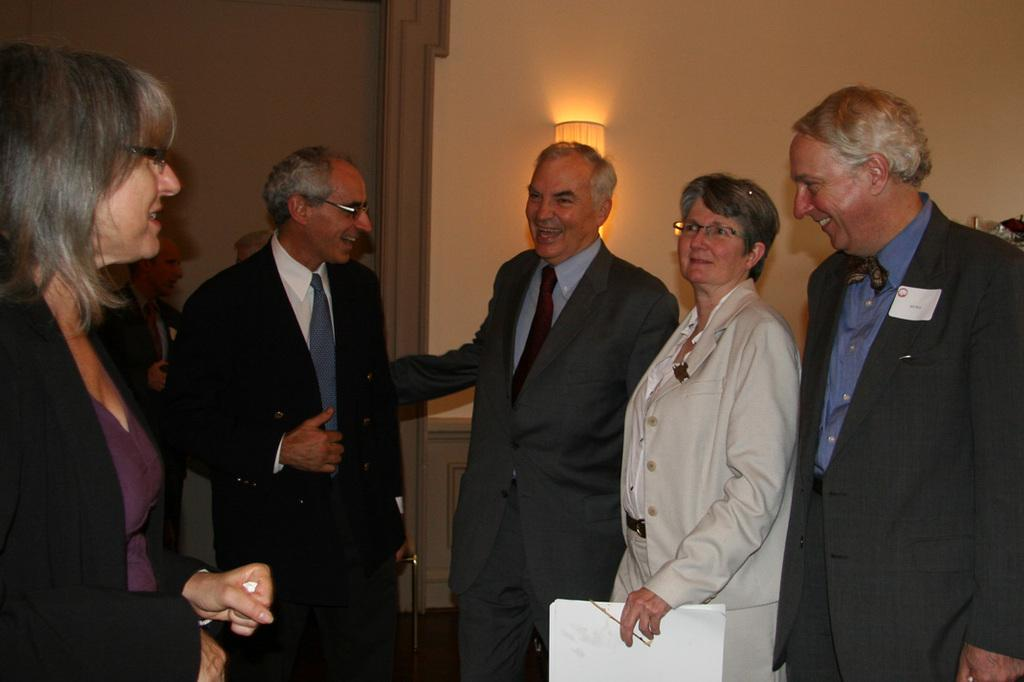How many people are in the image? There are many persons standing on the ground in the image. What can be seen in the background of the image? There is a wall and light visible in the background of the image. What type of stick is being used by the passengers in the image? There are no passengers or sticks present in the image. How does the behavior of the persons in the image change throughout the day? The provided facts do not give information about the behavior of the persons or the time of day, so we cannot answer this question. 